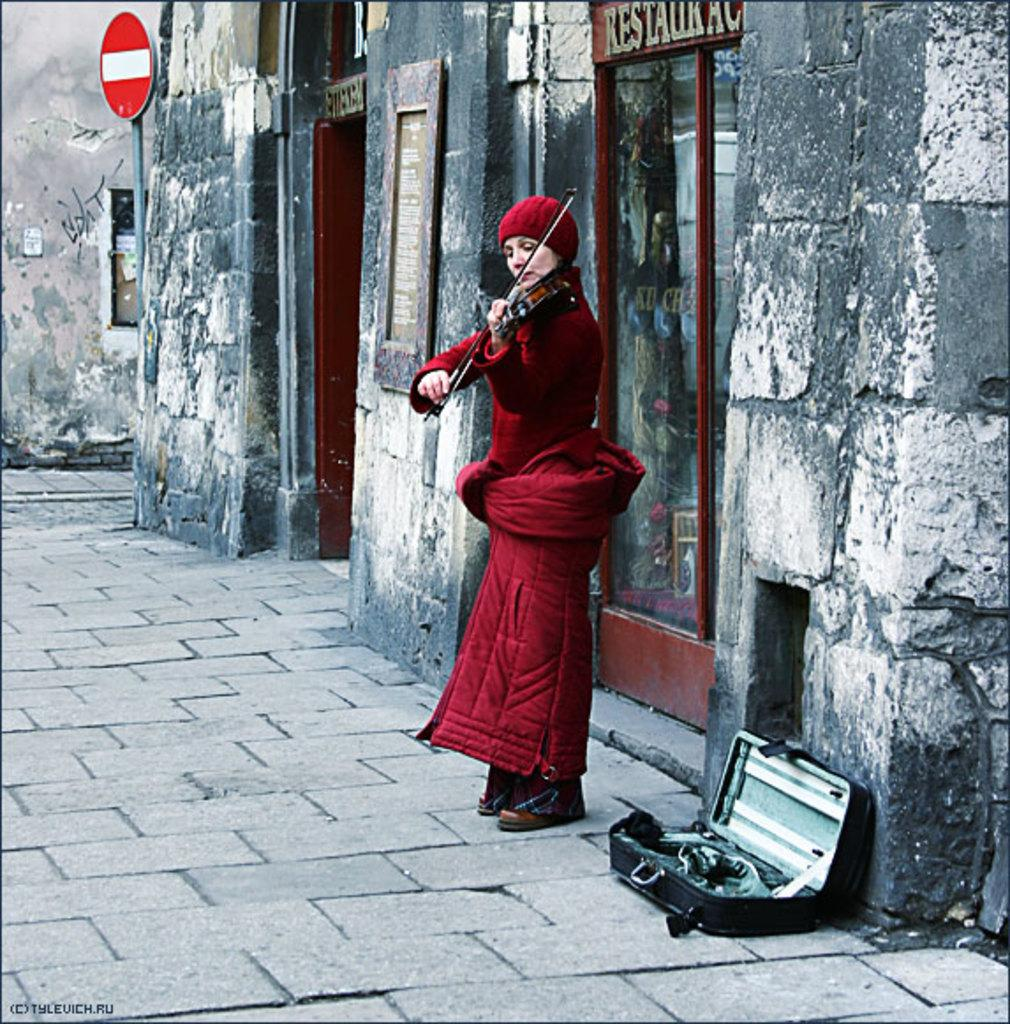Who is the main subject in the image? There is a lady person in the image. What is the lady person wearing? The lady person is wearing a red dress. What is the lady person doing in the image? The lady person is playing a violin. What can be seen in the background of the image? There is a wall in the background of the image. What type of tank is visible in the image? There is no tank present in the image. Can you describe the vase on the table next to the lady person? There is no vase present in the image; the lady person is playing a violin. 